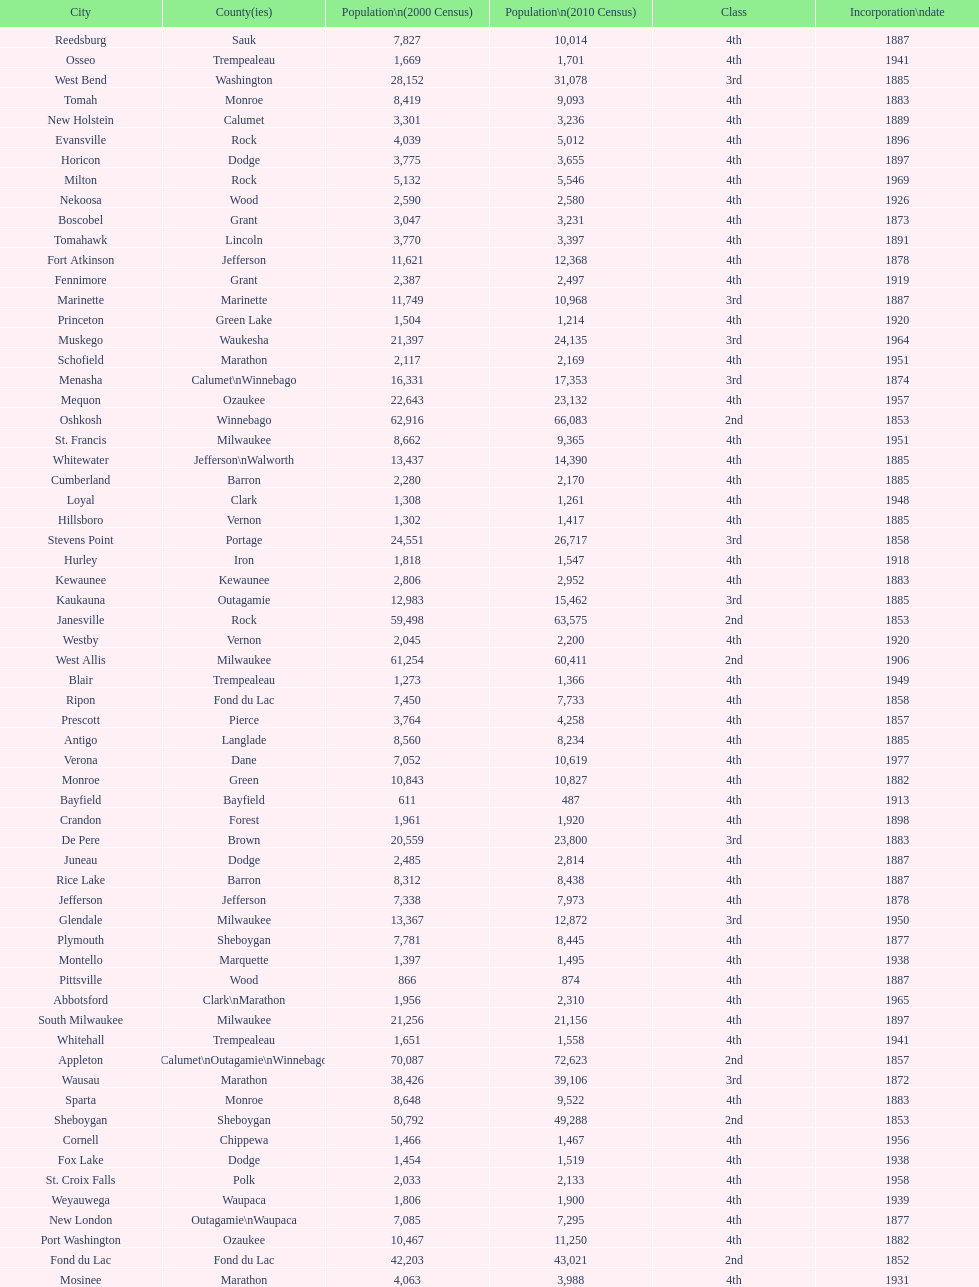How many cities have 1926 as their incorporation date? 2. 